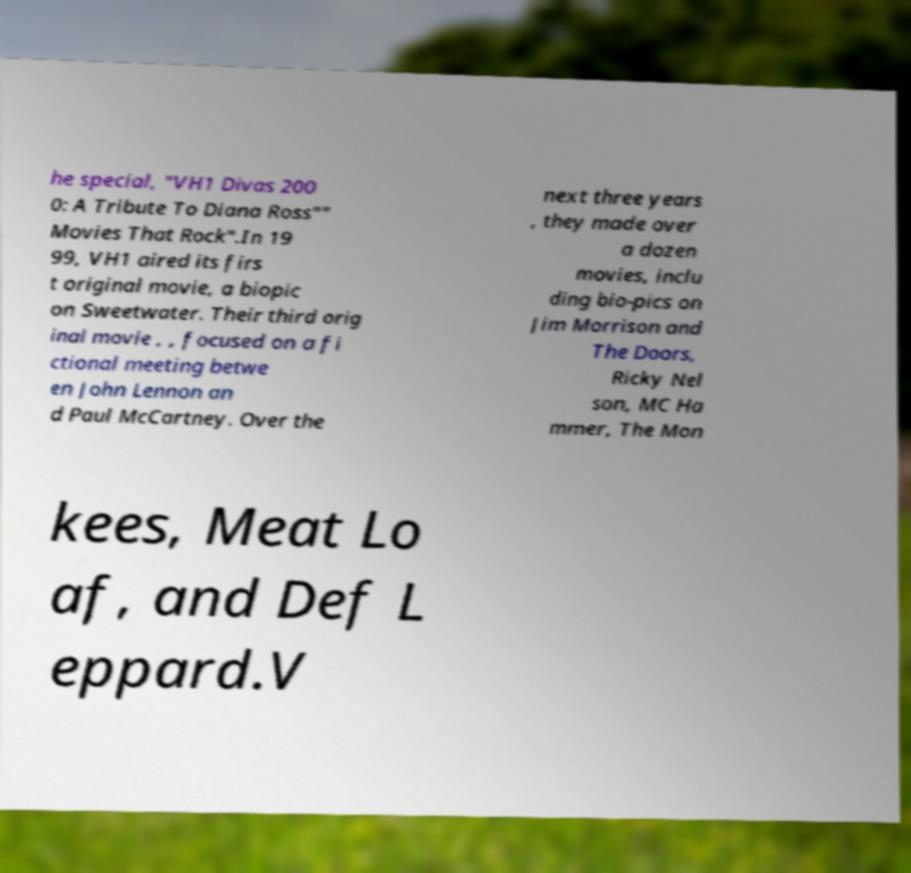Please read and relay the text visible in this image. What does it say? he special, "VH1 Divas 200 0: A Tribute To Diana Ross"" Movies That Rock".In 19 99, VH1 aired its firs t original movie, a biopic on Sweetwater. Their third orig inal movie , , focused on a fi ctional meeting betwe en John Lennon an d Paul McCartney. Over the next three years , they made over a dozen movies, inclu ding bio-pics on Jim Morrison and The Doors, Ricky Nel son, MC Ha mmer, The Mon kees, Meat Lo af, and Def L eppard.V 